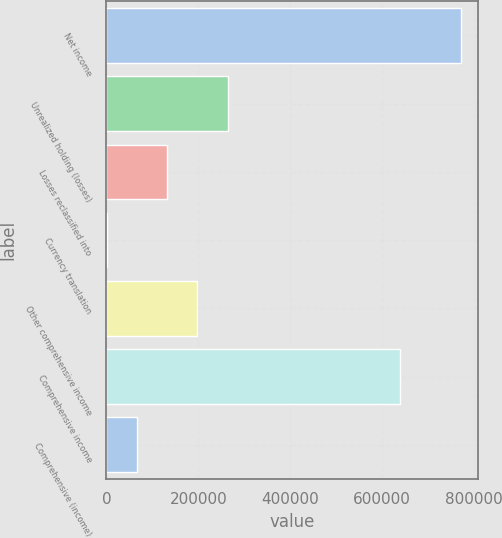Convert chart. <chart><loc_0><loc_0><loc_500><loc_500><bar_chart><fcel>Net income<fcel>Unrealized holding (losses)<fcel>Losses reclassified into<fcel>Currency translation<fcel>Other comprehensive income<fcel>Comprehensive income<fcel>Comprehensive (income)<nl><fcel>770775<fcel>263804<fcel>132178<fcel>552<fcel>197991<fcel>639149<fcel>66365.1<nl></chart> 